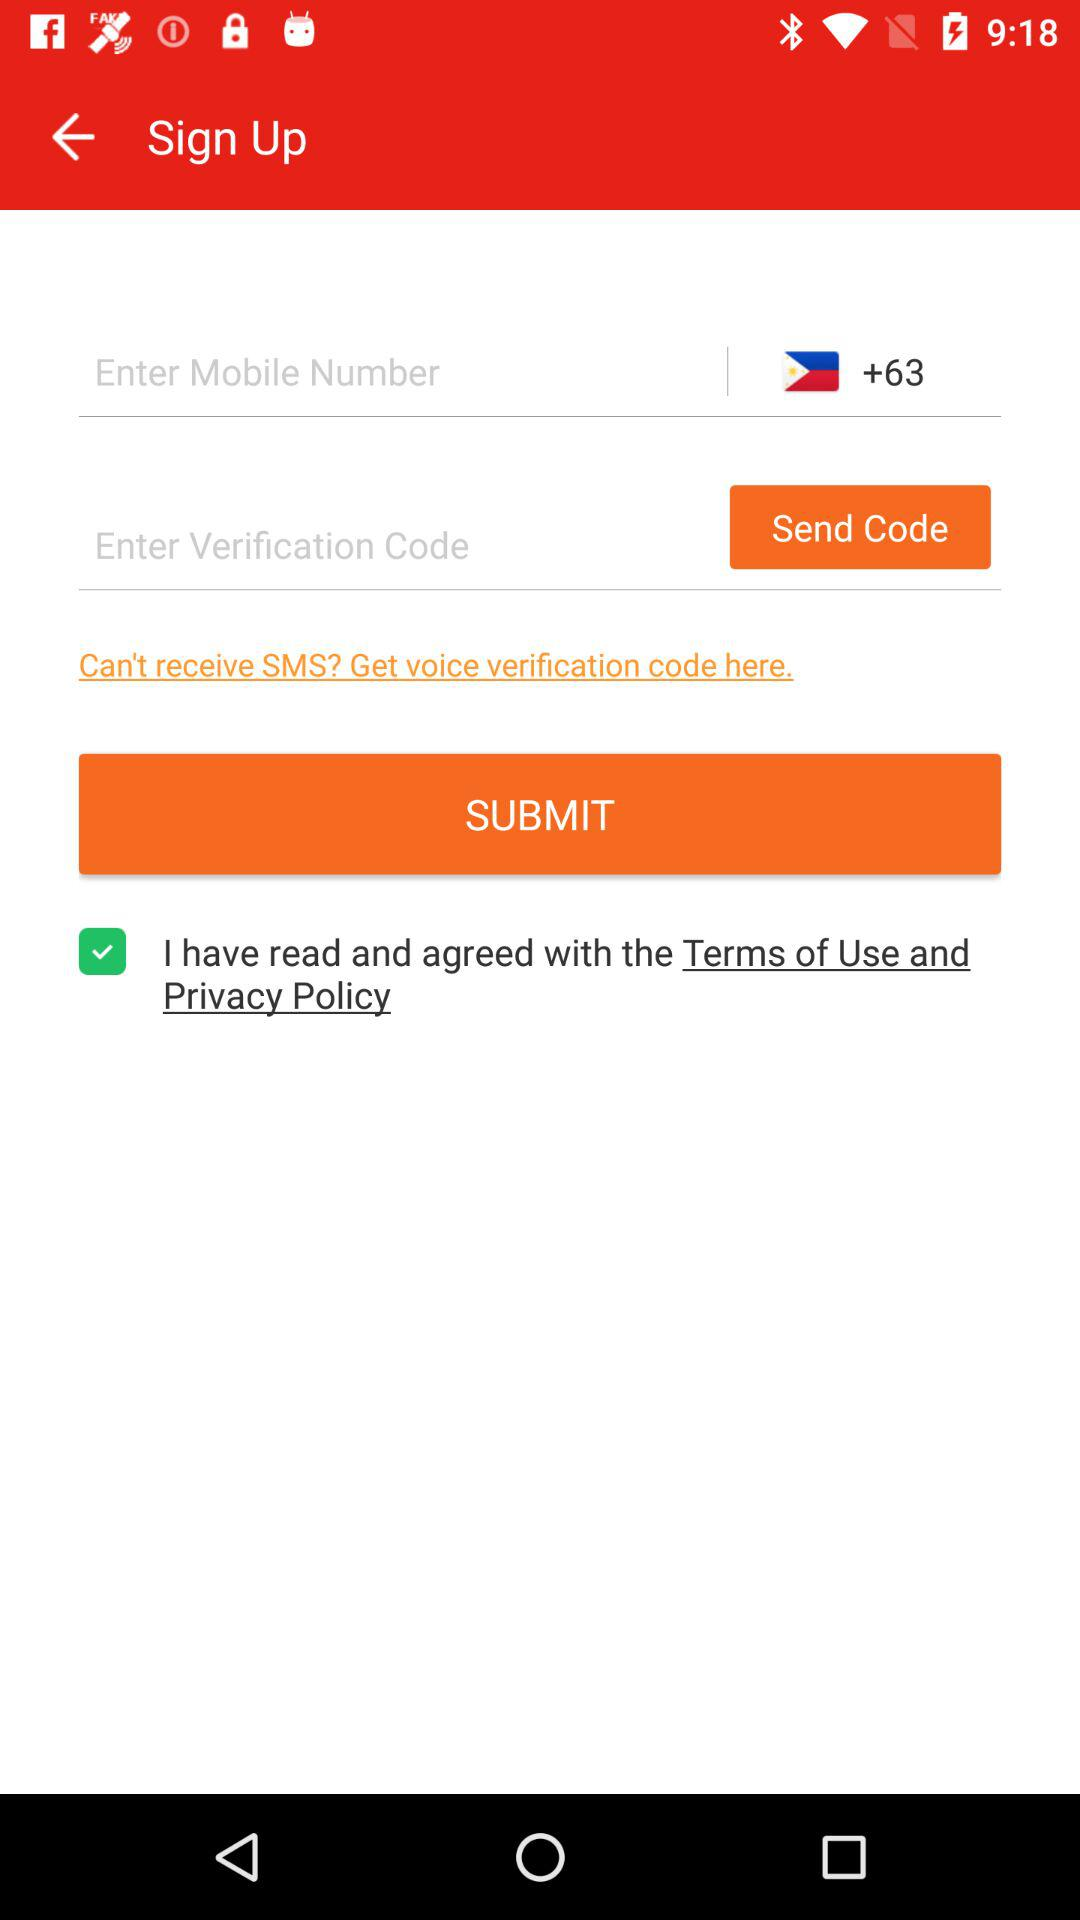What is the status of the option that includes agreement to the “Terms of Use and Privacy Policy”? The status is "on". 